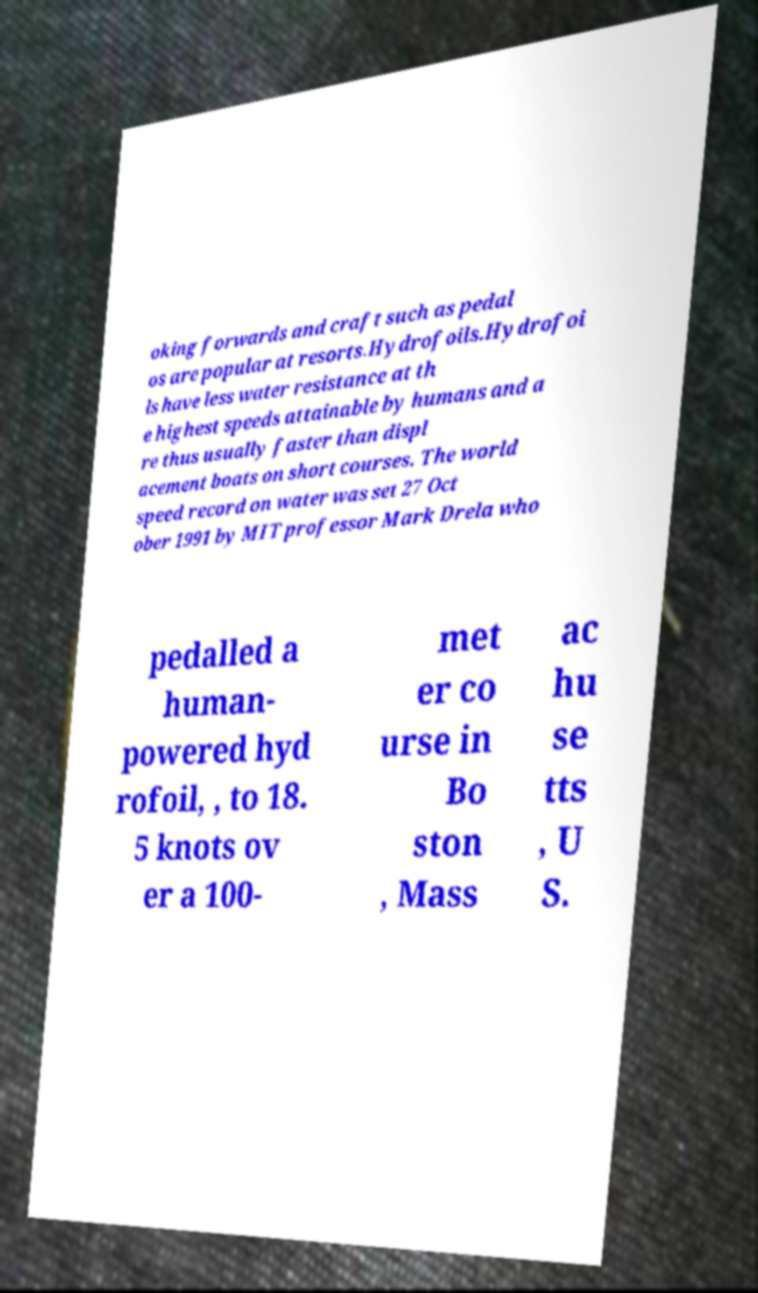I need the written content from this picture converted into text. Can you do that? oking forwards and craft such as pedal os are popular at resorts.Hydrofoils.Hydrofoi ls have less water resistance at th e highest speeds attainable by humans and a re thus usually faster than displ acement boats on short courses. The world speed record on water was set 27 Oct ober 1991 by MIT professor Mark Drela who pedalled a human- powered hyd rofoil, , to 18. 5 knots ov er a 100- met er co urse in Bo ston , Mass ac hu se tts , U S. 